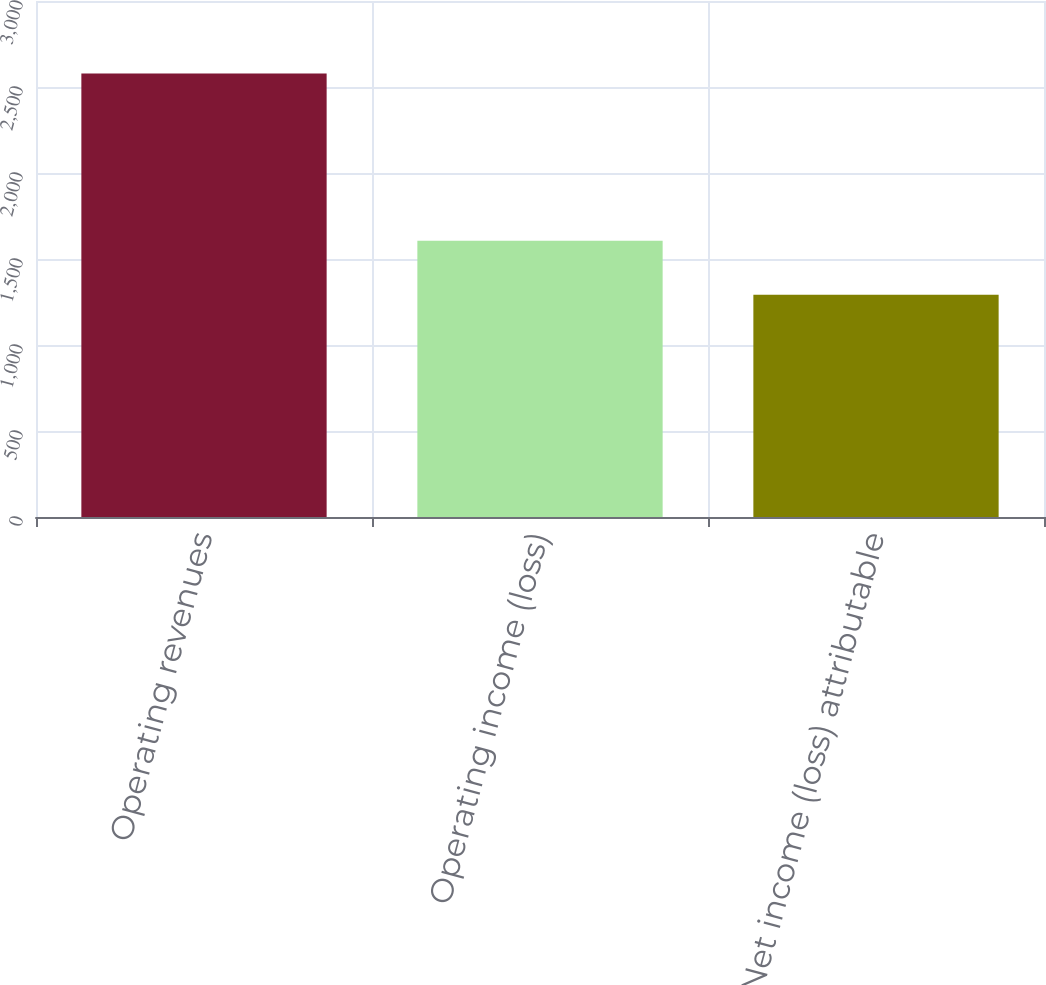<chart> <loc_0><loc_0><loc_500><loc_500><bar_chart><fcel>Operating revenues<fcel>Operating income (loss)<fcel>Net income (loss) attributable<nl><fcel>2578<fcel>1606<fcel>1292<nl></chart> 